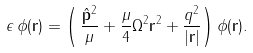Convert formula to latex. <formula><loc_0><loc_0><loc_500><loc_500>\epsilon \, \phi ( { \mathbf r } ) = \left ( \, \frac { \hat { \mathbf p } ^ { 2 } } { \mu } + \frac { \mu } { 4 } \Omega ^ { 2 } { \mathbf r } ^ { 2 } + \frac { q ^ { 2 } } { | { \mathbf r } | } \right ) \phi ( { \mathbf r } ) .</formula> 